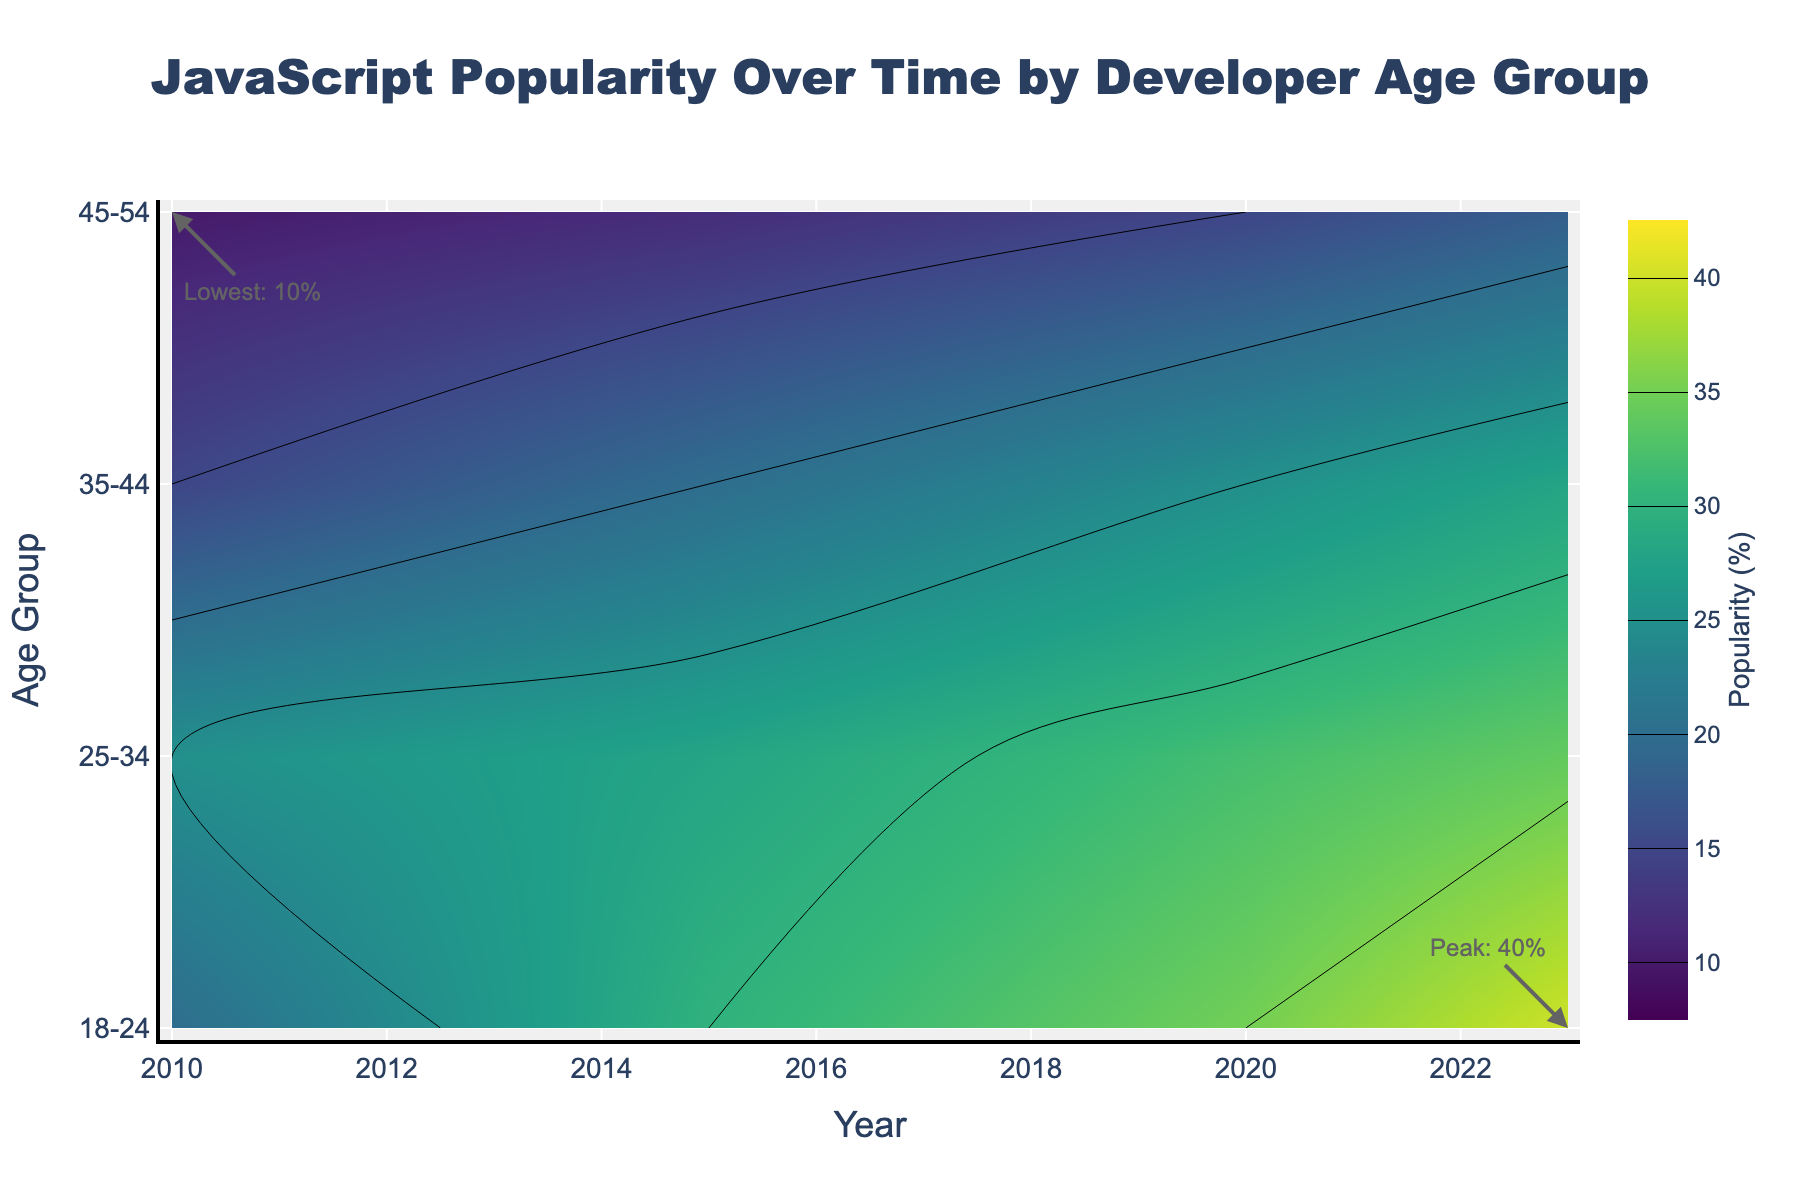What is the title of the figure? The title is usually located at the top of the figure. Here, it reads "JavaScript Popularity Over Time by Developer Age Group".
Answer: JavaScript Popularity Over Time by Developer Age Group What is the color scale used in the contour plot? By closely observing the colors in the figure, it appears the plot uses a gradient scale of colors from the Viridis color palette, which ranges from dark purple to yellow.
Answer: Viridis Which age group reached the peak popularity of JavaScript in 2023? The annotations on the figure help identify that the 18-24 age group reached the peak popularity of JavaScript, marked as 40%.
Answer: 18-24 What is the lowest observed popularity of JavaScript in 2010, and in which age group? The annotations indicate that the lowest popularity observed in 2010 is 10%, which occurred in the 45-54 age group.
Answer: 10%, 45-54 How did the popularity of JavaScript change for the 18-24 age group from 2010 to 2023? Observing from the figure, the popularity in the 18-24 age group increased from 20% in 2010 to 40% in 2023, showing a steady upward trend.
Answer: Increased from 20% to 40% Between which years did the 25-34 age group experience the most significant drop in JavaScript popularity? By observing the values, it appears the popularity dropped from 30% in 2010 to 25% in 2015, a more significant decline compared to other year intervals.
Answer: 2010 to 2015 Which age group had the highest popularity in 2010, and what was the percentage? In 2010, the age group 25-34 had the highest JavaScript popularity at 25%.
Answer: 25-34, 25% Which age group showed the least change in the popularity of JavaScript over the years, based on the contour plot? Analyzing the contour plot, the age group 35-44 seems to show relatively minor changes compared to others, with values around 15% to 28% across the years.
Answer: 35-44 How does the popularity level for the age group 45-54 in 2023 compare to its level in 2010? The 45-54 age group had a popularity of 10% in 2010 and increased to 18% in 2023.
Answer: Increased from 10% to 18% Which two age groups had the same JavaScript popularity in 2020, and what was the value? Observing the plot, both the 18-24 and 25-34 age groups had JavaScript popularity at 30% in 2020.
Answer: 18-24 and 25-34, 30% 